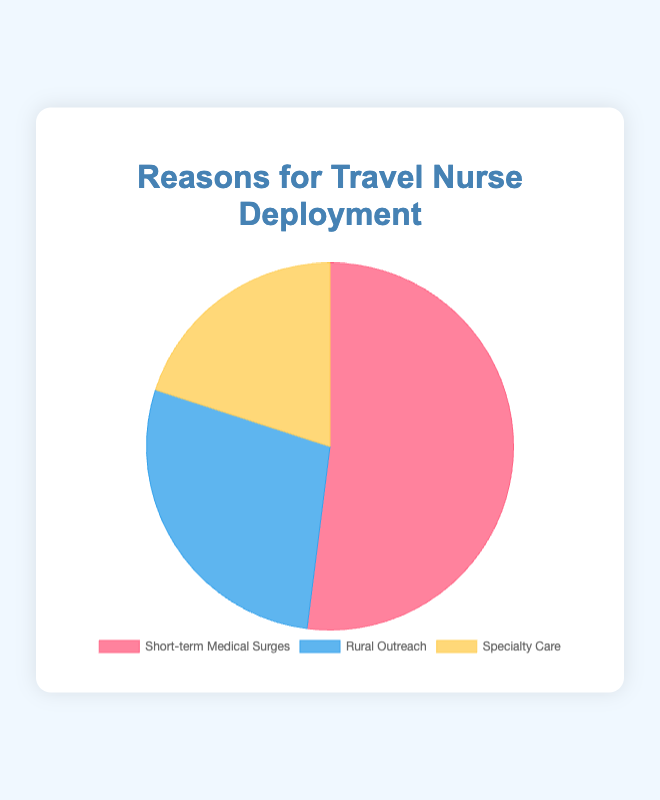What is the most common reason for travel nurse deployment? By examining the sizes of the pie chart sections, the largest section is for 'Short-term Medical Surges' which takes up the majority portion of the chart.
Answer: Short-term Medical Surges Which reason has the second highest percentage of cases? The pie chart shows that following 'Short-term Medical Surges', the next largest segment represents 'Rural Outreach'.
Answer: Rural Outreach How much larger is the percentage for 'Short-term Medical Surges' compared to 'Specialty Care'? To find the difference, subtract the percentage of 'Specialty Care' from 'Short-term Medical Surges': 52% - 20% = 32%.
Answer: 32% What is the combined percentage for Rural Outreach and Specialty Care? Add the percentages for 'Rural Outreach' and 'Specialty Care': 28% + 20% = 48%.
Answer: 48% Which section of the pie chart is colored red? By looking at the chart, the 'Short-term Medical Surges' section is colored red.
Answer: Short-term Medical Surges What percentage of cases does not relate to 'Short-term Medical Surges'? Subtract the 'Short-term Medical Surges' percentage from 100%: 100% - 52% = 48%.
Answer: 48% Are the combined cases of 'Rural Outreach' and 'Specialty Care' greater than the cases of 'Short-term Medical Surges'? Add the percentages of 'Rural Outreach' and 'Specialty Care' (28% + 20%) and compare it with 'Short-term Medical Surges' (52%): 48% is less than 52%.
Answer: No What is the percentage difference between 'Rural Outreach' and 'Specialty Care'? To find the difference, subtract the percentage of 'Specialty Care' from 'Rural Outreach': 28% - 20% = 8%.
Answer: 8% Does 'Rural Outreach' account for more than a quarter of the cases? Compare the percentage of 'Rural Outreach' to 25%. Since 28% is greater than 25%, 'Rural Outreach' accounts for more than a quarter.
Answer: Yes 